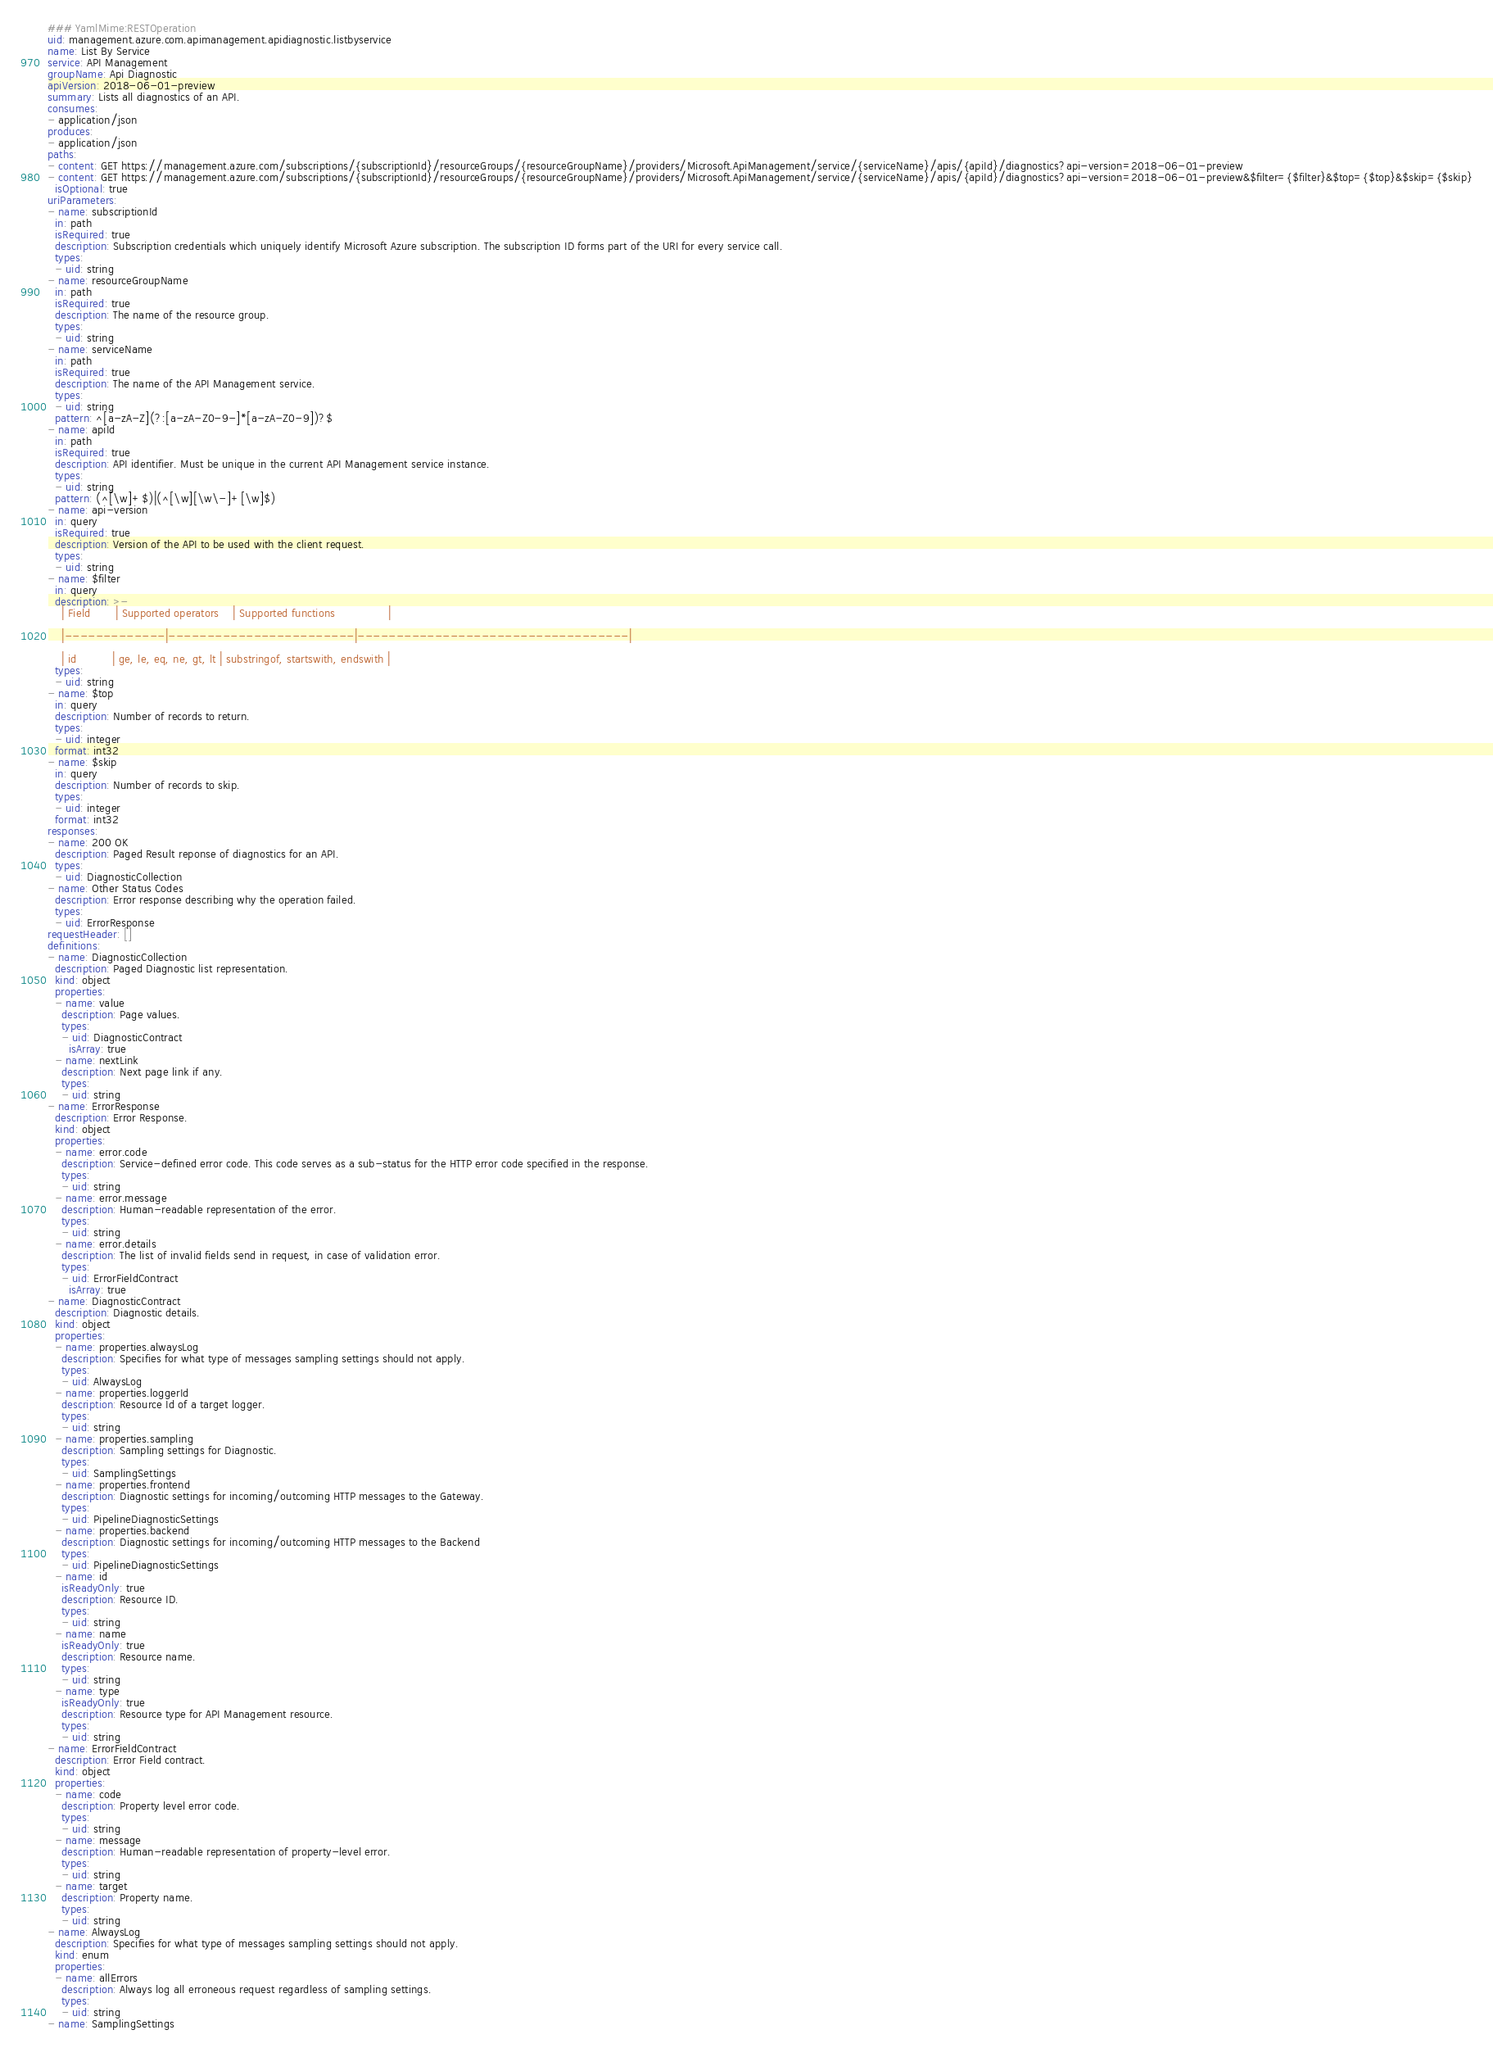Convert code to text. <code><loc_0><loc_0><loc_500><loc_500><_YAML_>### YamlMime:RESTOperation
uid: management.azure.com.apimanagement.apidiagnostic.listbyservice
name: List By Service
service: API Management
groupName: Api Diagnostic
apiVersion: 2018-06-01-preview
summary: Lists all diagnostics of an API.
consumes:
- application/json
produces:
- application/json
paths:
- content: GET https://management.azure.com/subscriptions/{subscriptionId}/resourceGroups/{resourceGroupName}/providers/Microsoft.ApiManagement/service/{serviceName}/apis/{apiId}/diagnostics?api-version=2018-06-01-preview
- content: GET https://management.azure.com/subscriptions/{subscriptionId}/resourceGroups/{resourceGroupName}/providers/Microsoft.ApiManagement/service/{serviceName}/apis/{apiId}/diagnostics?api-version=2018-06-01-preview&$filter={$filter}&$top={$top}&$skip={$skip}
  isOptional: true
uriParameters:
- name: subscriptionId
  in: path
  isRequired: true
  description: Subscription credentials which uniquely identify Microsoft Azure subscription. The subscription ID forms part of the URI for every service call.
  types:
  - uid: string
- name: resourceGroupName
  in: path
  isRequired: true
  description: The name of the resource group.
  types:
  - uid: string
- name: serviceName
  in: path
  isRequired: true
  description: The name of the API Management service.
  types:
  - uid: string
  pattern: ^[a-zA-Z](?:[a-zA-Z0-9-]*[a-zA-Z0-9])?$
- name: apiId
  in: path
  isRequired: true
  description: API identifier. Must be unique in the current API Management service instance.
  types:
  - uid: string
  pattern: (^[\w]+$)|(^[\w][\w\-]+[\w]$)
- name: api-version
  in: query
  isRequired: true
  description: Version of the API to be used with the client request.
  types:
  - uid: string
- name: $filter
  in: query
  description: >-
    | Field       | Supported operators    | Supported functions               |

    |-------------|------------------------|-----------------------------------|

    | id          | ge, le, eq, ne, gt, lt | substringof, startswith, endswith |
  types:
  - uid: string
- name: $top
  in: query
  description: Number of records to return.
  types:
  - uid: integer
  format: int32
- name: $skip
  in: query
  description: Number of records to skip.
  types:
  - uid: integer
  format: int32
responses:
- name: 200 OK
  description: Paged Result reponse of diagnostics for an API.
  types:
  - uid: DiagnosticCollection
- name: Other Status Codes
  description: Error response describing why the operation failed.
  types:
  - uid: ErrorResponse
requestHeader: []
definitions:
- name: DiagnosticCollection
  description: Paged Diagnostic list representation.
  kind: object
  properties:
  - name: value
    description: Page values.
    types:
    - uid: DiagnosticContract
      isArray: true
  - name: nextLink
    description: Next page link if any.
    types:
    - uid: string
- name: ErrorResponse
  description: Error Response.
  kind: object
  properties:
  - name: error.code
    description: Service-defined error code. This code serves as a sub-status for the HTTP error code specified in the response.
    types:
    - uid: string
  - name: error.message
    description: Human-readable representation of the error.
    types:
    - uid: string
  - name: error.details
    description: The list of invalid fields send in request, in case of validation error.
    types:
    - uid: ErrorFieldContract
      isArray: true
- name: DiagnosticContract
  description: Diagnostic details.
  kind: object
  properties:
  - name: properties.alwaysLog
    description: Specifies for what type of messages sampling settings should not apply.
    types:
    - uid: AlwaysLog
  - name: properties.loggerId
    description: Resource Id of a target logger.
    types:
    - uid: string
  - name: properties.sampling
    description: Sampling settings for Diagnostic.
    types:
    - uid: SamplingSettings
  - name: properties.frontend
    description: Diagnostic settings for incoming/outcoming HTTP messages to the Gateway.
    types:
    - uid: PipelineDiagnosticSettings
  - name: properties.backend
    description: Diagnostic settings for incoming/outcoming HTTP messages to the Backend
    types:
    - uid: PipelineDiagnosticSettings
  - name: id
    isReadyOnly: true
    description: Resource ID.
    types:
    - uid: string
  - name: name
    isReadyOnly: true
    description: Resource name.
    types:
    - uid: string
  - name: type
    isReadyOnly: true
    description: Resource type for API Management resource.
    types:
    - uid: string
- name: ErrorFieldContract
  description: Error Field contract.
  kind: object
  properties:
  - name: code
    description: Property level error code.
    types:
    - uid: string
  - name: message
    description: Human-readable representation of property-level error.
    types:
    - uid: string
  - name: target
    description: Property name.
    types:
    - uid: string
- name: AlwaysLog
  description: Specifies for what type of messages sampling settings should not apply.
  kind: enum
  properties:
  - name: allErrors
    description: Always log all erroneous request regardless of sampling settings.
    types:
    - uid: string
- name: SamplingSettings</code> 